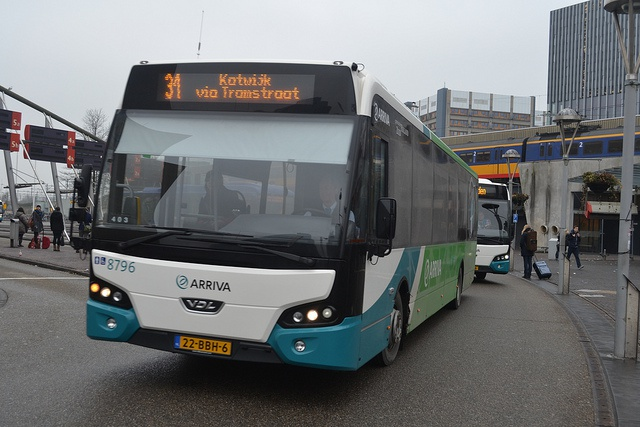Describe the objects in this image and their specific colors. I can see bus in lightgray, gray, black, darkgray, and teal tones, train in lightgray, black, navy, gray, and darkblue tones, bus in lightgray, black, gray, darkgray, and blue tones, people in lightgray and gray tones, and people in lightgray, gray, and black tones in this image. 